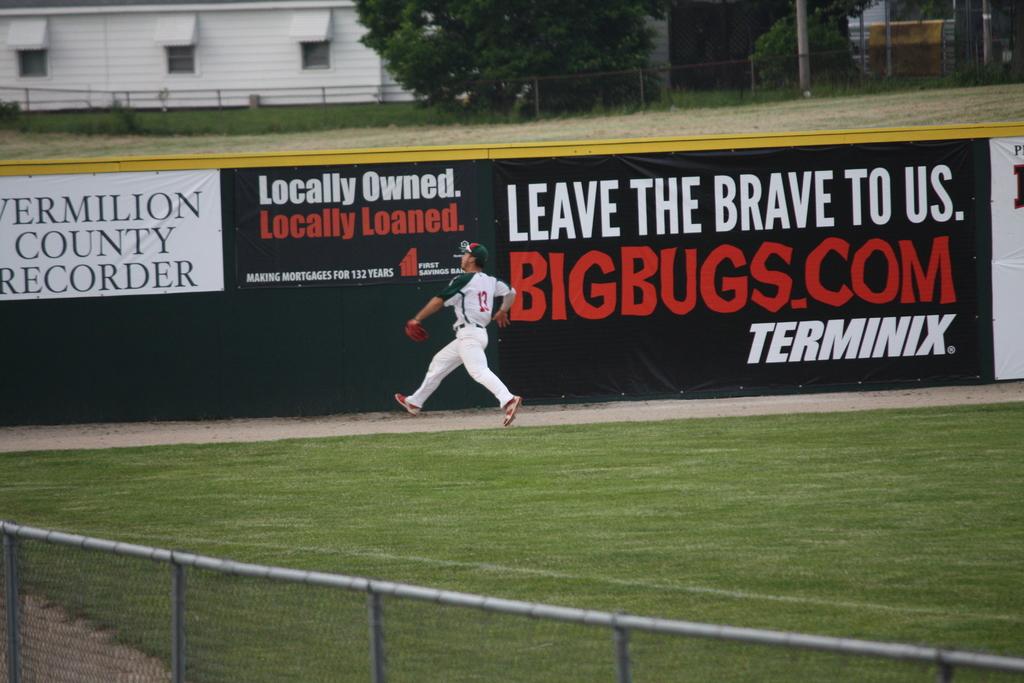Who should you leave the brave to?
Give a very brief answer. Us. Whats the advert about?
Make the answer very short. Terminix. 